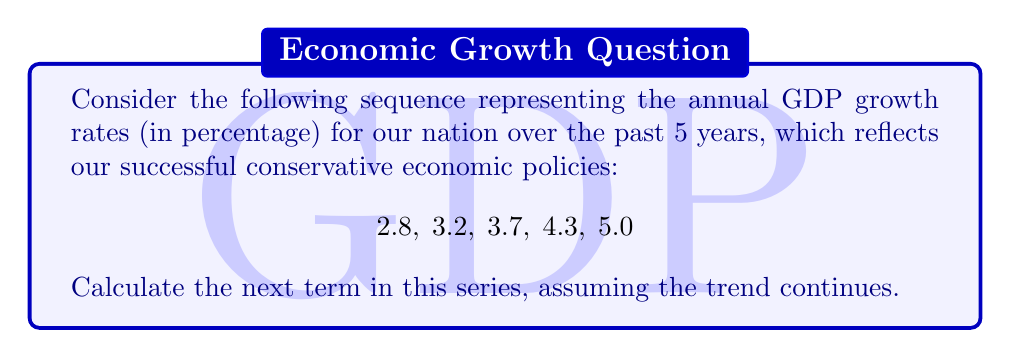What is the answer to this math problem? To solve this problem, we need to analyze the pattern in the given sequence:

1. First, calculate the differences between consecutive terms:
   $3.2 - 2.8 = 0.4$
   $3.7 - 3.2 = 0.5$
   $4.3 - 3.7 = 0.6$
   $5.0 - 4.3 = 0.7$

2. We observe that the differences are increasing by 0.1 each time:
   $0.4 \rightarrow 0.5 \rightarrow 0.6 \rightarrow 0.7$

3. Following this pattern, the next difference should be:
   $0.7 + 0.1 = 0.8$

4. To find the next term in the original sequence, we add this difference to the last given term:
   $5.0 + 0.8 = 5.8$

Therefore, the next term in the sequence, representing the projected GDP growth rate for the upcoming year, is 5.8%.
Answer: 5.8 